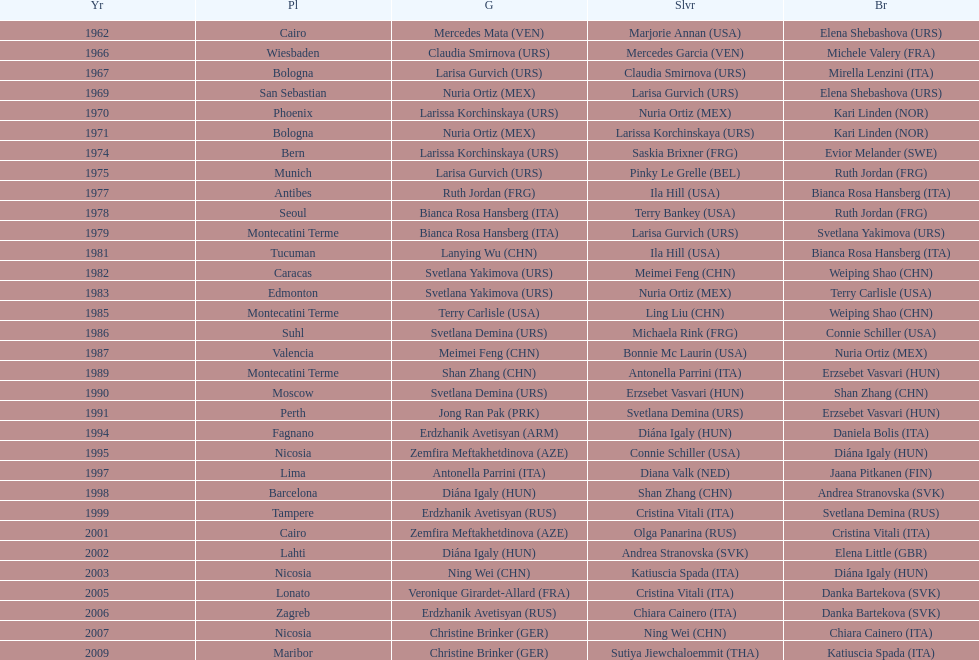In which nation can the highest number of bronze medals be found? Italy. Would you be able to parse every entry in this table? {'header': ['Yr', 'Pl', 'G', 'Slvr', 'Br'], 'rows': [['1962', 'Cairo', 'Mercedes Mata\xa0(VEN)', 'Marjorie Annan\xa0(USA)', 'Elena Shebashova\xa0(URS)'], ['1966', 'Wiesbaden', 'Claudia Smirnova\xa0(URS)', 'Mercedes Garcia\xa0(VEN)', 'Michele Valery\xa0(FRA)'], ['1967', 'Bologna', 'Larisa Gurvich\xa0(URS)', 'Claudia Smirnova\xa0(URS)', 'Mirella Lenzini\xa0(ITA)'], ['1969', 'San Sebastian', 'Nuria Ortiz\xa0(MEX)', 'Larisa Gurvich\xa0(URS)', 'Elena Shebashova\xa0(URS)'], ['1970', 'Phoenix', 'Larissa Korchinskaya\xa0(URS)', 'Nuria Ortiz\xa0(MEX)', 'Kari Linden\xa0(NOR)'], ['1971', 'Bologna', 'Nuria Ortiz\xa0(MEX)', 'Larissa Korchinskaya\xa0(URS)', 'Kari Linden\xa0(NOR)'], ['1974', 'Bern', 'Larissa Korchinskaya\xa0(URS)', 'Saskia Brixner\xa0(FRG)', 'Evior Melander\xa0(SWE)'], ['1975', 'Munich', 'Larisa Gurvich\xa0(URS)', 'Pinky Le Grelle\xa0(BEL)', 'Ruth Jordan\xa0(FRG)'], ['1977', 'Antibes', 'Ruth Jordan\xa0(FRG)', 'Ila Hill\xa0(USA)', 'Bianca Rosa Hansberg\xa0(ITA)'], ['1978', 'Seoul', 'Bianca Rosa Hansberg\xa0(ITA)', 'Terry Bankey\xa0(USA)', 'Ruth Jordan\xa0(FRG)'], ['1979', 'Montecatini Terme', 'Bianca Rosa Hansberg\xa0(ITA)', 'Larisa Gurvich\xa0(URS)', 'Svetlana Yakimova\xa0(URS)'], ['1981', 'Tucuman', 'Lanying Wu\xa0(CHN)', 'Ila Hill\xa0(USA)', 'Bianca Rosa Hansberg\xa0(ITA)'], ['1982', 'Caracas', 'Svetlana Yakimova\xa0(URS)', 'Meimei Feng\xa0(CHN)', 'Weiping Shao\xa0(CHN)'], ['1983', 'Edmonton', 'Svetlana Yakimova\xa0(URS)', 'Nuria Ortiz\xa0(MEX)', 'Terry Carlisle\xa0(USA)'], ['1985', 'Montecatini Terme', 'Terry Carlisle\xa0(USA)', 'Ling Liu\xa0(CHN)', 'Weiping Shao\xa0(CHN)'], ['1986', 'Suhl', 'Svetlana Demina\xa0(URS)', 'Michaela Rink\xa0(FRG)', 'Connie Schiller\xa0(USA)'], ['1987', 'Valencia', 'Meimei Feng\xa0(CHN)', 'Bonnie Mc Laurin\xa0(USA)', 'Nuria Ortiz\xa0(MEX)'], ['1989', 'Montecatini Terme', 'Shan Zhang\xa0(CHN)', 'Antonella Parrini\xa0(ITA)', 'Erzsebet Vasvari\xa0(HUN)'], ['1990', 'Moscow', 'Svetlana Demina\xa0(URS)', 'Erzsebet Vasvari\xa0(HUN)', 'Shan Zhang\xa0(CHN)'], ['1991', 'Perth', 'Jong Ran Pak\xa0(PRK)', 'Svetlana Demina\xa0(URS)', 'Erzsebet Vasvari\xa0(HUN)'], ['1994', 'Fagnano', 'Erdzhanik Avetisyan\xa0(ARM)', 'Diána Igaly\xa0(HUN)', 'Daniela Bolis\xa0(ITA)'], ['1995', 'Nicosia', 'Zemfira Meftakhetdinova\xa0(AZE)', 'Connie Schiller\xa0(USA)', 'Diána Igaly\xa0(HUN)'], ['1997', 'Lima', 'Antonella Parrini\xa0(ITA)', 'Diana Valk\xa0(NED)', 'Jaana Pitkanen\xa0(FIN)'], ['1998', 'Barcelona', 'Diána Igaly\xa0(HUN)', 'Shan Zhang\xa0(CHN)', 'Andrea Stranovska\xa0(SVK)'], ['1999', 'Tampere', 'Erdzhanik Avetisyan\xa0(RUS)', 'Cristina Vitali\xa0(ITA)', 'Svetlana Demina\xa0(RUS)'], ['2001', 'Cairo', 'Zemfira Meftakhetdinova\xa0(AZE)', 'Olga Panarina\xa0(RUS)', 'Cristina Vitali\xa0(ITA)'], ['2002', 'Lahti', 'Diána Igaly\xa0(HUN)', 'Andrea Stranovska\xa0(SVK)', 'Elena Little\xa0(GBR)'], ['2003', 'Nicosia', 'Ning Wei\xa0(CHN)', 'Katiuscia Spada\xa0(ITA)', 'Diána Igaly\xa0(HUN)'], ['2005', 'Lonato', 'Veronique Girardet-Allard\xa0(FRA)', 'Cristina Vitali\xa0(ITA)', 'Danka Bartekova\xa0(SVK)'], ['2006', 'Zagreb', 'Erdzhanik Avetisyan\xa0(RUS)', 'Chiara Cainero\xa0(ITA)', 'Danka Bartekova\xa0(SVK)'], ['2007', 'Nicosia', 'Christine Brinker\xa0(GER)', 'Ning Wei\xa0(CHN)', 'Chiara Cainero\xa0(ITA)'], ['2009', 'Maribor', 'Christine Brinker\xa0(GER)', 'Sutiya Jiewchaloemmit\xa0(THA)', 'Katiuscia Spada\xa0(ITA)']]} 